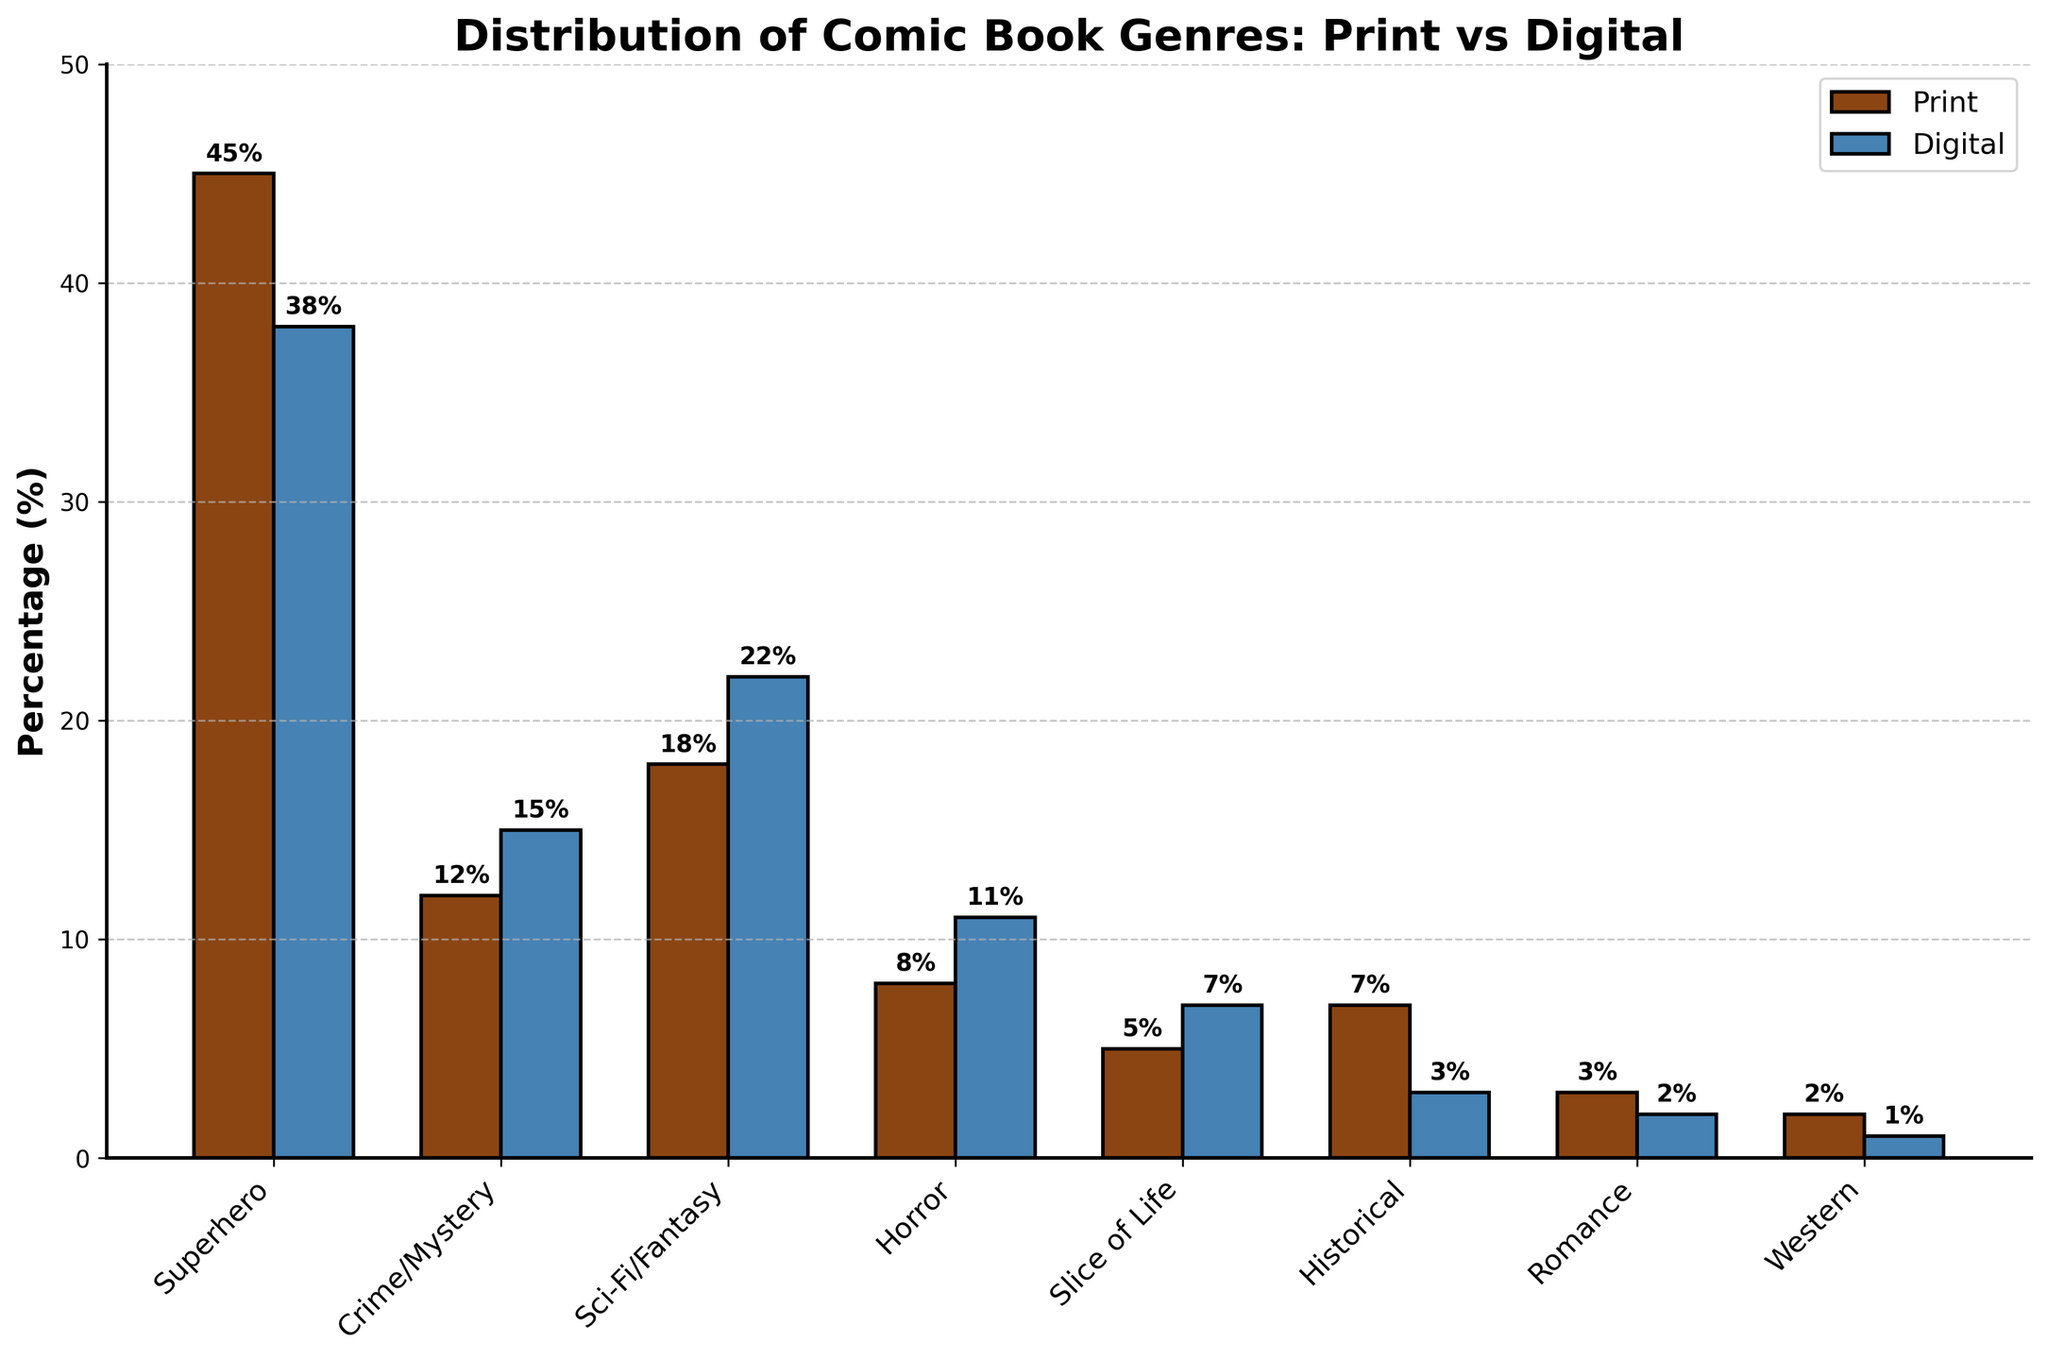what's the combined percentage of superhero comics in both print and digital formats? First, look at the bar heights for the superhero genre in both print and digital formats. The print percentage is 45%, and the digital percentage is 38%. Adding them together, 45 + 38 = 83
Answer: 83 which genre has a higher percentage in digital format compared to print? Compare all bar heights for each genre between print and digital formats. The genres with higher percentages in digital format are Crime/Mystery (digital 15%, print 12%), Sci-Fi/Fantasy (digital 22%, print 18%), Horror (digital 11%, print 8%), and Slice of Life (digital 7%, print 5%)
Answer: Crime/Mystery, Sci-Fi/Fantasy, Horror, Slice of Life how does the percentage of sci-fi/fantasy comics in digital format compare to the superhero comics in print format? Refer to the bar heights for Sci-Fi/Fantasy in digital (22%) and Superhero in print (45%). The sci-fi/fantasy percentage is less than the superhero percentage
Answer: less what is the total percentage of all genres in print format excluding superhero? First, exclude the superhero percentage in print (45%). Add the remaining print percentages: 12 + 18 + 8 + 5 + 7 + 3 + 2 = 55
Answer: 55 what is the overall trend between print and digital formats for all genres? Observe the general pattern of the bars. For most genres, the digital percentage tends to be slightly higher or comparable to the print percentage, except for Historical, Romance, and Western genres where the print percentage is higher.
Answer: digital comparable or higher which genre has the largest percentage in both print and digital formats combined? Combine the percentages for each genre and find the largest:
- Superhero: 45 + 38 = 83
- Crime/Mystery: 12 + 15 = 27
- Sci-Fi/Fantasy: 18 + 22 = 40
- Horror: 8 + 11 = 19
- Slice of Life: 5 + 7 = 12
- Historical: 7 + 3 = 10
- Romance: 3 + 2 = 5
- Western: 2 + 1 = 3
Superhero has the largest combined percentage.
Answer: Superhero which genre in print is least represented compared to digital? Identify the genres where the print percentage is less than the digital percentage:
- Crime/Mystery: 12 < 15
- Sci-Fi/Fantasy: 18 < 22
- Horror: 8 < 11
- Slice of Life: 5 < 7
The genre with the smallest print percentage relative to its digital percentage is Slice of Life.
Answer: Slice of Life 